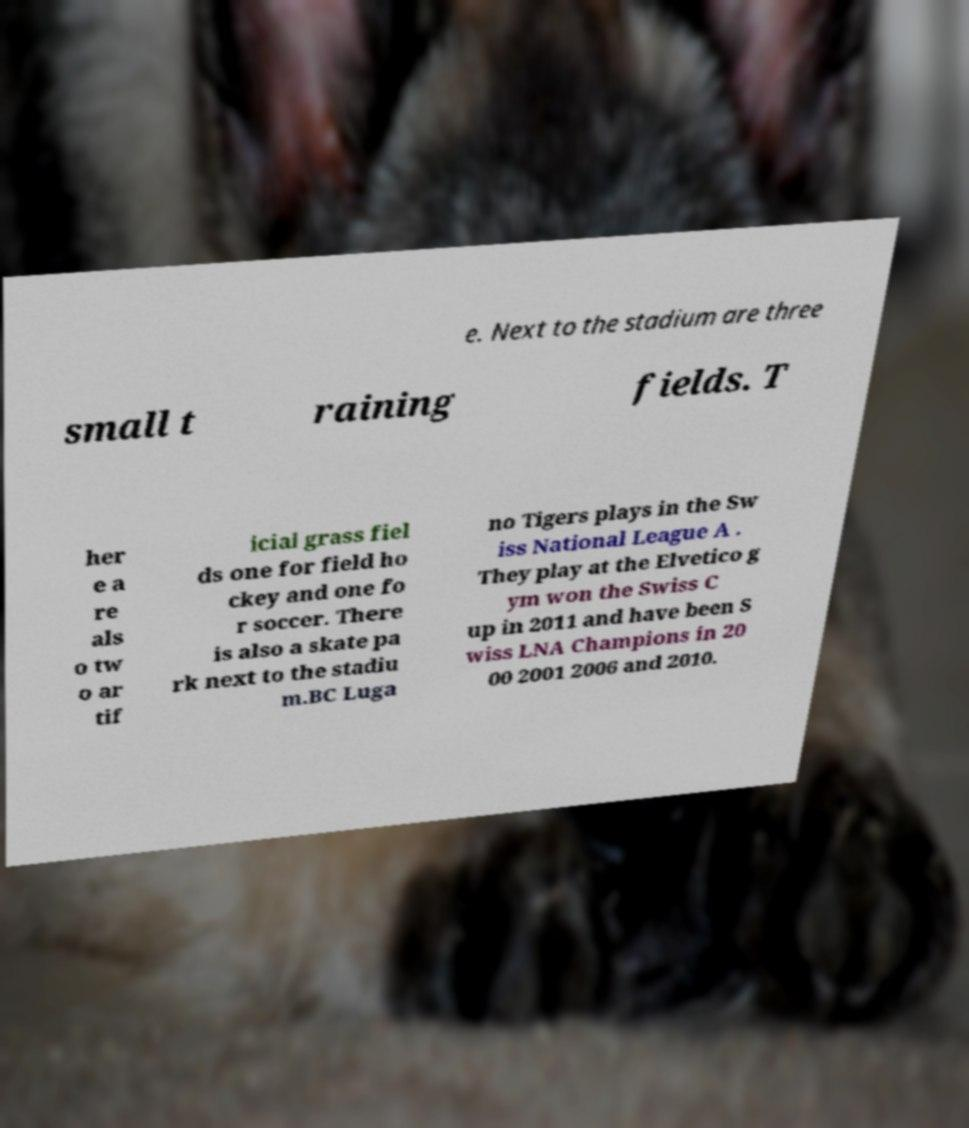There's text embedded in this image that I need extracted. Can you transcribe it verbatim? e. Next to the stadium are three small t raining fields. T her e a re als o tw o ar tif icial grass fiel ds one for field ho ckey and one fo r soccer. There is also a skate pa rk next to the stadiu m.BC Luga no Tigers plays in the Sw iss National League A . They play at the Elvetico g ym won the Swiss C up in 2011 and have been S wiss LNA Champions in 20 00 2001 2006 and 2010. 